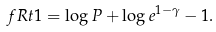Convert formula to latex. <formula><loc_0><loc_0><loc_500><loc_500>\ f R t { 1 } & = \log P + \log e ^ { 1 - \gamma } - 1 .</formula> 